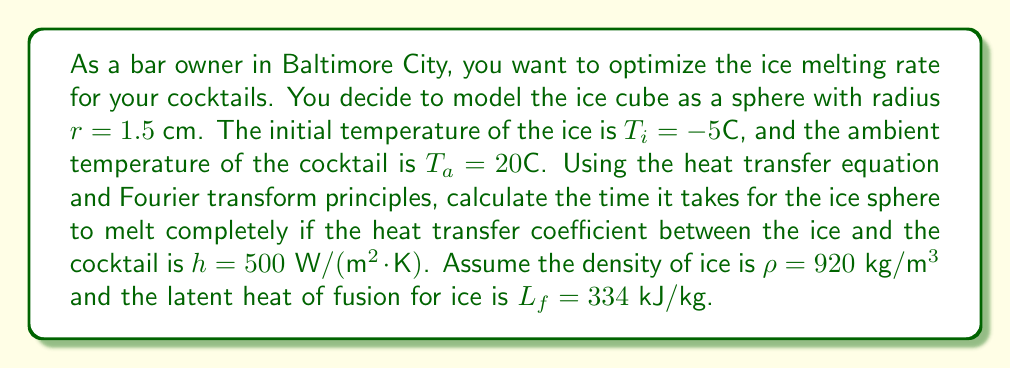Can you solve this math problem? To solve this problem, we'll use the heat transfer equation and apply Fourier transform principles. Let's break it down step by step:

1. First, we need to calculate the volume and surface area of the ice sphere:
   Volume: $V = \frac{4}{3}\pi r^3 = \frac{4}{3}\pi (0.015 \text{ m})^3 = 1.4137 \times 10^{-5} \text{ m}^3$
   Surface area: $A = 4\pi r^2 = 4\pi (0.015 \text{ m})^2 = 2.8274 \times 10^{-3} \text{ m}^2$

2. The total heat required to melt the ice sphere is the sum of the heat needed to raise the temperature to 0°C and the heat needed for the phase change:
   $Q_{total} = Q_{heating} + Q_{melting}$

3. Calculate $Q_{heating}$:
   $Q_{heating} = mc\Delta T = \rho V c \Delta T$
   where $c$ is the specific heat capacity of ice (2108 J/(kg·K))
   $Q_{heating} = 920 \cdot 1.4137 \times 10^{-5} \cdot 2108 \cdot (0 - (-5)) = 0.1371 \text{ kJ}$

4. Calculate $Q_{melting}$:
   $Q_{melting} = mL_f = \rho V L_f$
   $Q_{melting} = 920 \cdot 1.4137 \times 10^{-5} \cdot 334000 = 4.3410 \text{ kJ}$

5. Total heat required:
   $Q_{total} = 0.1371 + 4.3410 = 4.4781 \text{ kJ}$

6. Now, we use the heat transfer equation:
   $Q = hA(T_a - T_s)t$
   where $T_s$ is the surface temperature of the ice (0°C during melting)

7. Rearranging the equation to solve for time:
   $t = \frac{Q}{hA(T_a - T_s)}$

8. Substituting the values:
   $t = \frac{4.4781 \times 10^3}{500 \cdot 2.8274 \times 10^{-3} \cdot (20 - 0)} = 158.56 \text{ seconds}$

The Fourier transform principles come into play when considering the heat transfer as a function of time and position within the ice sphere. The solution to the heat equation in spherical coordinates involves Fourier series expansions, which can be transformed to the frequency domain using Fourier transforms. However, for this simplified problem, we've used the lumped capacitance method, assuming uniform temperature distribution within the ice sphere.
Answer: The time it takes for the ice sphere to melt completely is approximately 158.56 seconds or 2.64 minutes. 